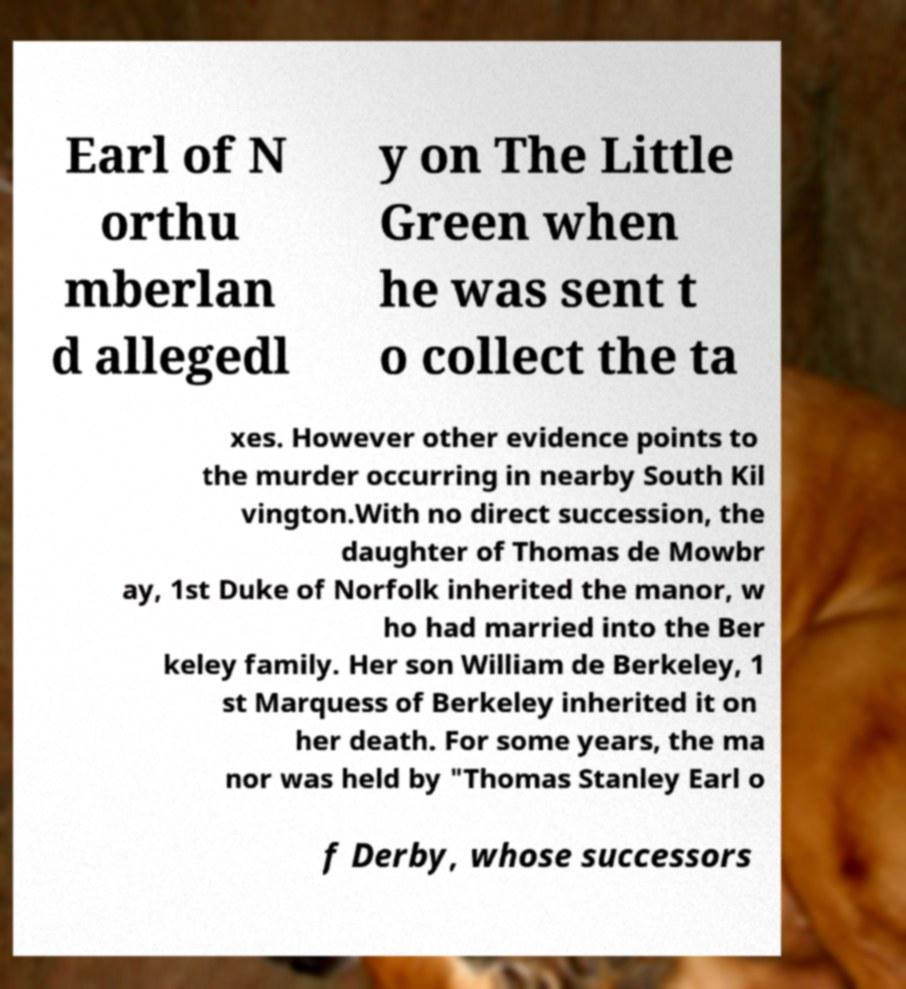For documentation purposes, I need the text within this image transcribed. Could you provide that? Earl of N orthu mberlan d allegedl y on The Little Green when he was sent t o collect the ta xes. However other evidence points to the murder occurring in nearby South Kil vington.With no direct succession, the daughter of Thomas de Mowbr ay, 1st Duke of Norfolk inherited the manor, w ho had married into the Ber keley family. Her son William de Berkeley, 1 st Marquess of Berkeley inherited it on her death. For some years, the ma nor was held by "Thomas Stanley Earl o f Derby, whose successors 